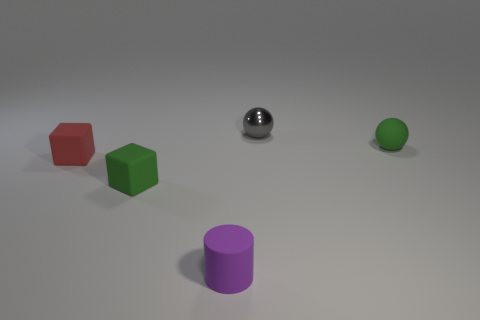Is there any other thing that has the same size as the gray shiny object?
Provide a succinct answer. Yes. There is a purple cylinder that is the same size as the gray metallic sphere; what is it made of?
Make the answer very short. Rubber. Is there another purple cylinder made of the same material as the cylinder?
Your answer should be very brief. No. What is the color of the tiny rubber block that is to the right of the tiny red matte block that is in front of the green thing that is right of the tiny purple rubber cylinder?
Your answer should be compact. Green. Is the color of the tiny sphere that is to the right of the gray ball the same as the small object that is behind the green sphere?
Make the answer very short. No. Is there anything else that has the same color as the cylinder?
Make the answer very short. No. Are there fewer blocks to the right of the small red rubber block than blue cylinders?
Your answer should be very brief. No. How many big cyan cylinders are there?
Offer a terse response. 0. There is a gray thing; does it have the same shape as the tiny green object that is in front of the small green ball?
Make the answer very short. No. Are there fewer tiny green cubes behind the gray object than red objects that are on the right side of the green ball?
Provide a short and direct response. No. 